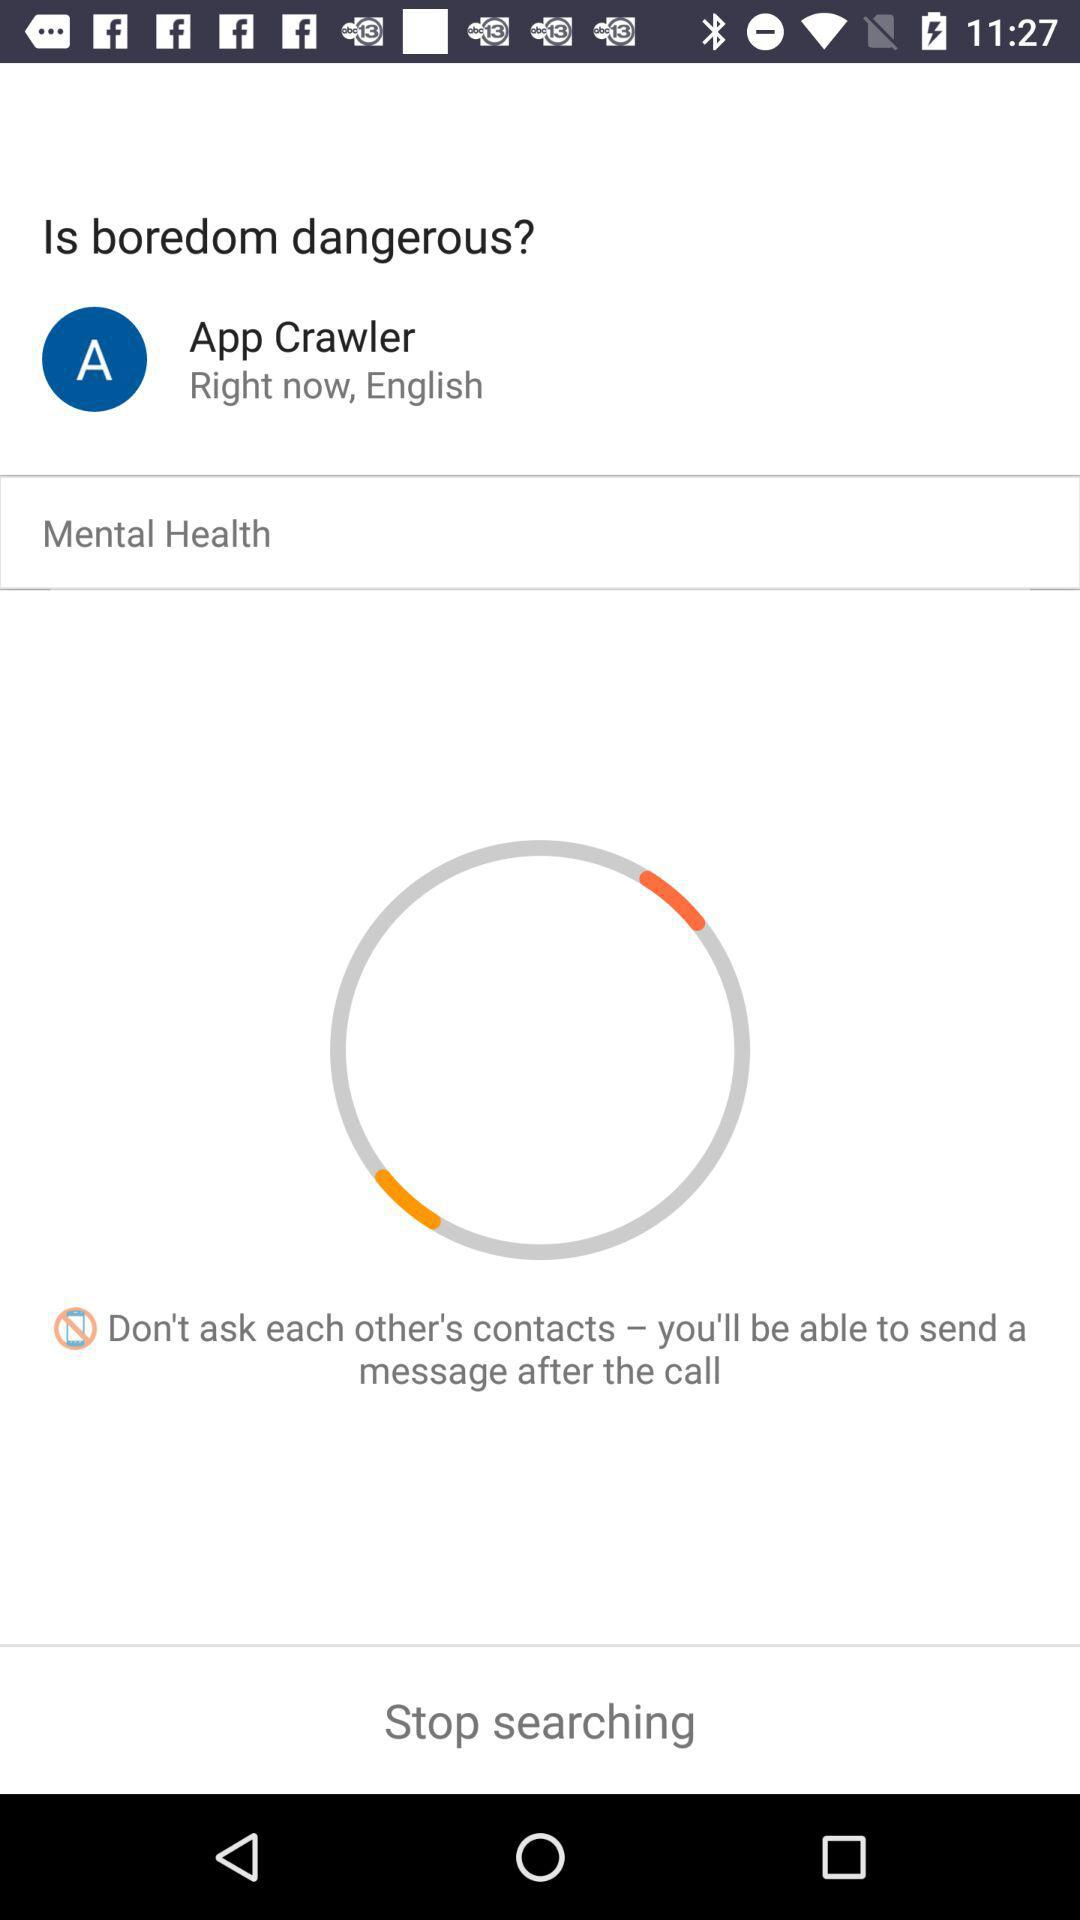What is the user name? The user name is App Crawler. 